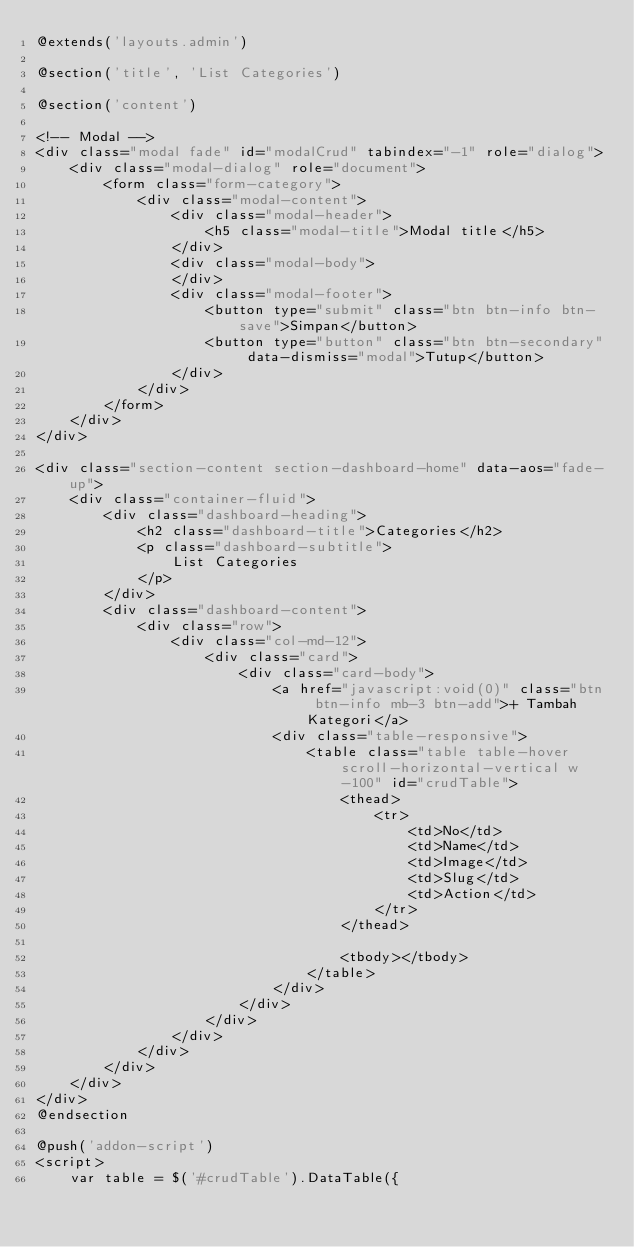Convert code to text. <code><loc_0><loc_0><loc_500><loc_500><_PHP_>@extends('layouts.admin')

@section('title', 'List Categories')

@section('content')

<!-- Modal -->
<div class="modal fade" id="modalCrud" tabindex="-1" role="dialog">
    <div class="modal-dialog" role="document">
        <form class="form-category">
            <div class="modal-content">
                <div class="modal-header">
                    <h5 class="modal-title">Modal title</h5>
                </div>
                <div class="modal-body">
                </div>
                <div class="modal-footer">
                    <button type="submit" class="btn btn-info btn-save">Simpan</button>
                    <button type="button" class="btn btn-secondary" data-dismiss="modal">Tutup</button>
                </div>
            </div>
        </form>
    </div>
</div>

<div class="section-content section-dashboard-home" data-aos="fade-up">
    <div class="container-fluid">
        <div class="dashboard-heading">
            <h2 class="dashboard-title">Categories</h2>
            <p class="dashboard-subtitle">
                List Categories
            </p>
        </div>
        <div class="dashboard-content">
            <div class="row">
                <div class="col-md-12">
                    <div class="card">
                        <div class="card-body">
                            <a href="javascript:void(0)" class="btn btn-info mb-3 btn-add">+ Tambah Kategori</a>
                            <div class="table-responsive">
                                <table class="table table-hover scroll-horizontal-vertical w-100" id="crudTable">
                                    <thead>
                                        <tr>
                                            <td>No</td>
                                            <td>Name</td>
                                            <td>Image</td>
                                            <td>Slug</td>
                                            <td>Action</td>
                                        </tr>
                                    </thead>

                                    <tbody></tbody>
                                </table>
                            </div>
                        </div>
                    </div>
                </div>
            </div>
        </div>
    </div>
</div>
@endsection

@push('addon-script')
<script>
    var table = $('#crudTable').DataTable({</code> 